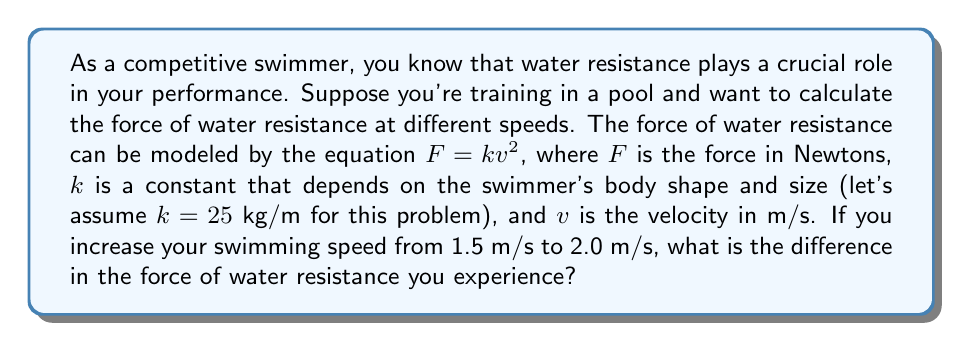Provide a solution to this math problem. To solve this problem, we need to calculate the force of water resistance at both speeds and then find the difference. Let's break it down step by step:

1. Given information:
   - Force equation: $F = kv^2$
   - Constant $k = 25$ kg/m
   - Initial speed $v_1 = 1.5$ m/s
   - Final speed $v_2 = 2.0$ m/s

2. Calculate the force at the initial speed (1.5 m/s):
   $$F_1 = k(v_1)^2 = 25 \cdot (1.5)^2 = 25 \cdot 2.25 = 56.25 \text{ N}$$

3. Calculate the force at the final speed (2.0 m/s):
   $$F_2 = k(v_2)^2 = 25 \cdot (2.0)^2 = 25 \cdot 4 = 100 \text{ N}$$

4. Calculate the difference in force:
   $$\Delta F = F_2 - F_1 = 100 - 56.25 = 43.75 \text{ N}$$

Therefore, the difference in the force of water resistance when increasing speed from 1.5 m/s to 2.0 m/s is 43.75 N.
Answer: 43.75 N 